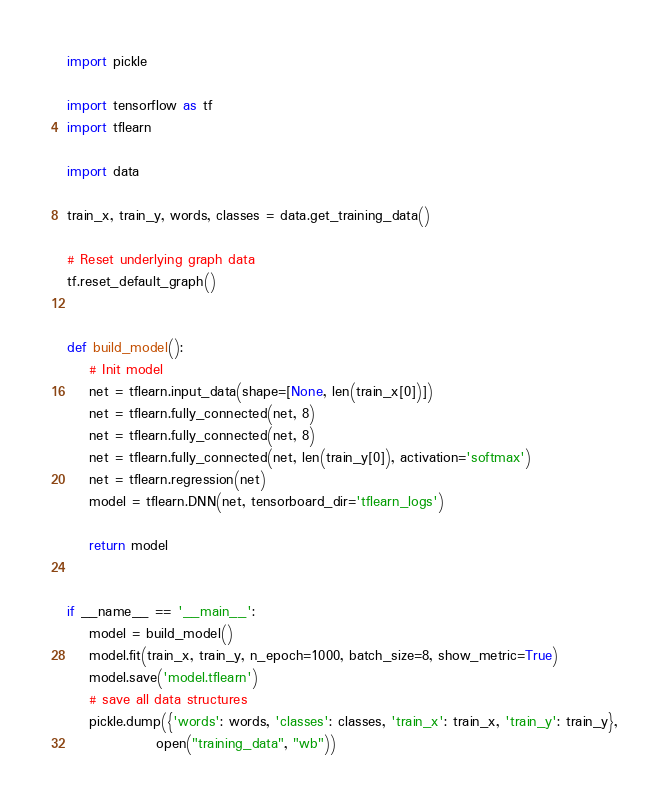<code> <loc_0><loc_0><loc_500><loc_500><_Python_>import pickle

import tensorflow as tf
import tflearn

import data

train_x, train_y, words, classes = data.get_training_data()

# Reset underlying graph data
tf.reset_default_graph()


def build_model():
    # Init model
    net = tflearn.input_data(shape=[None, len(train_x[0])])
    net = tflearn.fully_connected(net, 8)
    net = tflearn.fully_connected(net, 8)
    net = tflearn.fully_connected(net, len(train_y[0]), activation='softmax')
    net = tflearn.regression(net)
    model = tflearn.DNN(net, tensorboard_dir='tflearn_logs')

    return model


if __name__ == '__main__':
    model = build_model()
    model.fit(train_x, train_y, n_epoch=1000, batch_size=8, show_metric=True)
    model.save('model.tflearn')
    # save all data structures
    pickle.dump({'words': words, 'classes': classes, 'train_x': train_x, 'train_y': train_y},
                open("training_data", "wb"))
</code> 